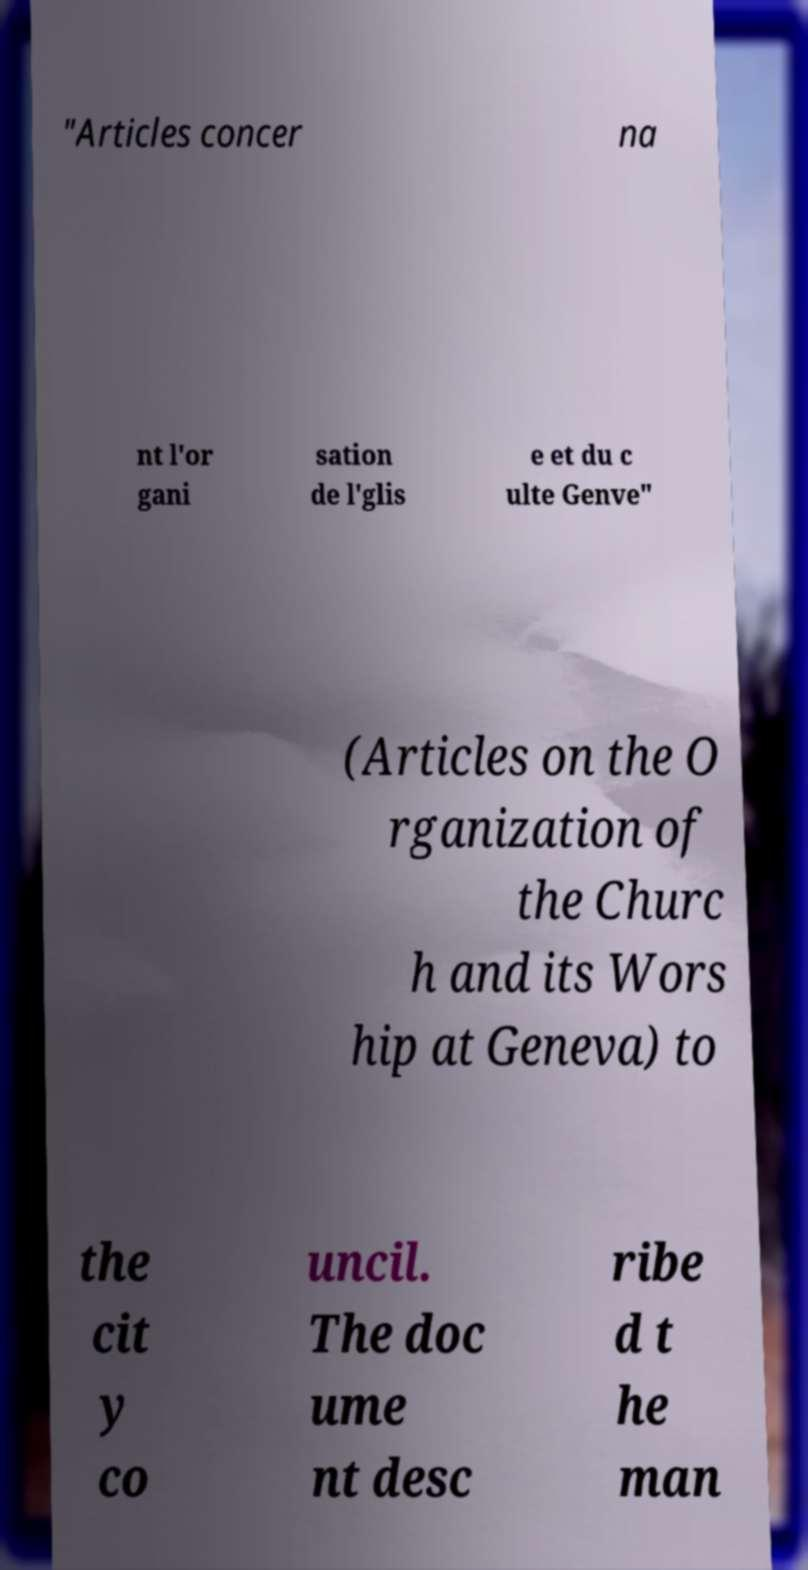For documentation purposes, I need the text within this image transcribed. Could you provide that? "Articles concer na nt l'or gani sation de l'glis e et du c ulte Genve" (Articles on the O rganization of the Churc h and its Wors hip at Geneva) to the cit y co uncil. The doc ume nt desc ribe d t he man 